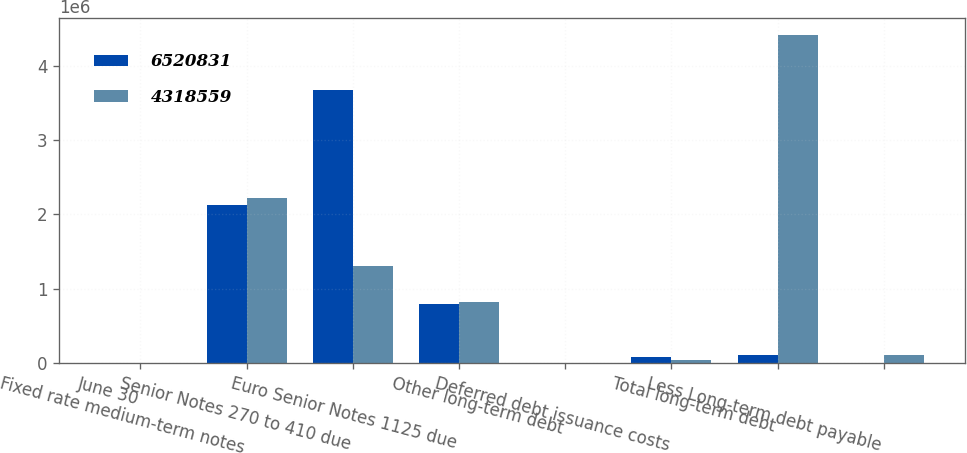Convert chart to OTSL. <chart><loc_0><loc_0><loc_500><loc_500><stacked_bar_chart><ecel><fcel>June 30<fcel>Fixed rate medium-term notes<fcel>Senior Notes 270 to 410 due<fcel>Euro Senior Notes 1125 due<fcel>Other long-term debt<fcel>Deferred debt issuance costs<fcel>Total long-term debt<fcel>Less Long-term debt payable<nl><fcel>6.52083e+06<fcel>2019<fcel>2.125e+06<fcel>3.675e+06<fcel>796040<fcel>340<fcel>75321<fcel>100411<fcel>228<nl><fcel>4.31856e+06<fcel>2018<fcel>2.225e+06<fcel>1.3e+06<fcel>817810<fcel>762<fcel>41432<fcel>4.41897e+06<fcel>100411<nl></chart> 